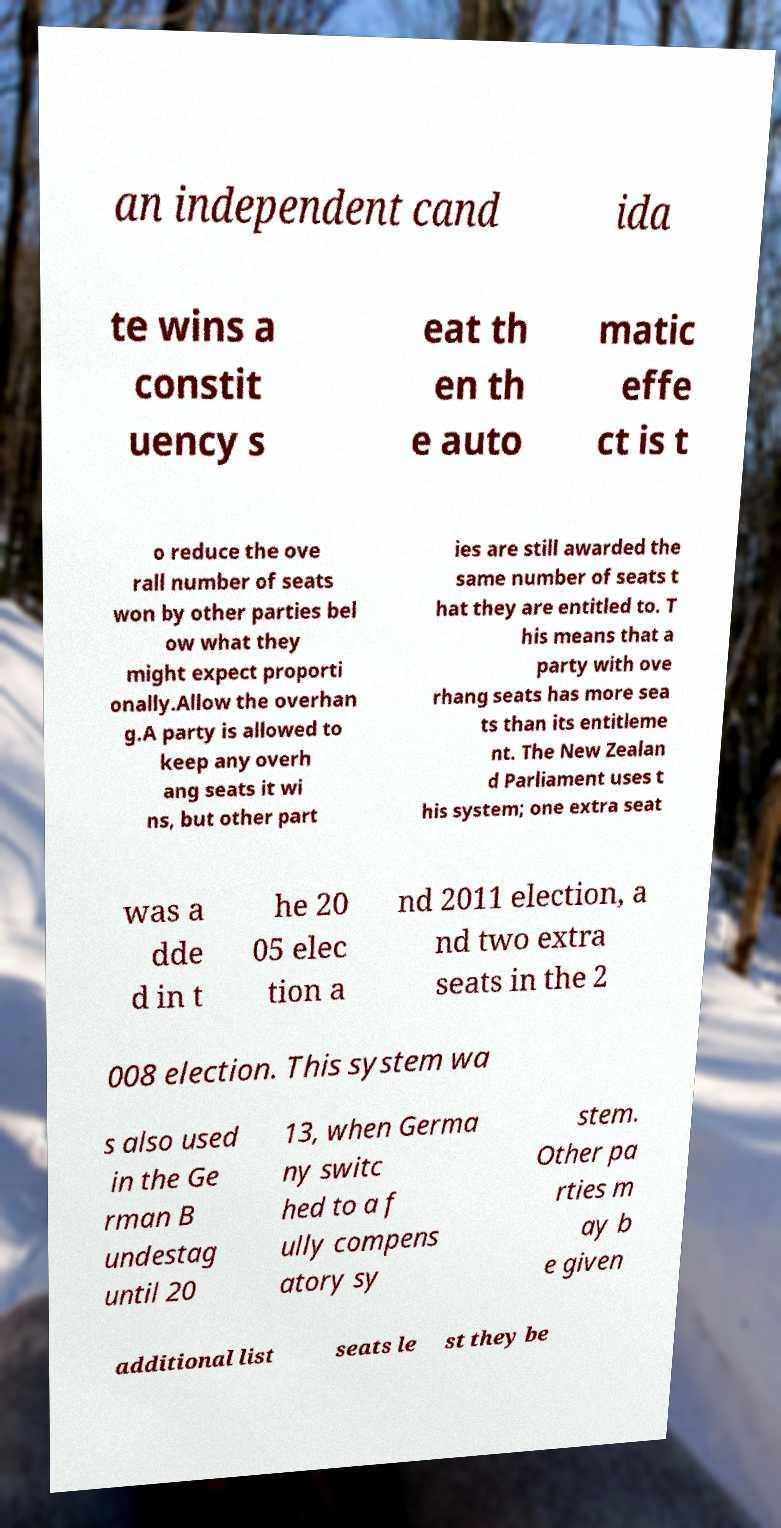Can you accurately transcribe the text from the provided image for me? an independent cand ida te wins a constit uency s eat th en th e auto matic effe ct is t o reduce the ove rall number of seats won by other parties bel ow what they might expect proporti onally.Allow the overhan g.A party is allowed to keep any overh ang seats it wi ns, but other part ies are still awarded the same number of seats t hat they are entitled to. T his means that a party with ove rhang seats has more sea ts than its entitleme nt. The New Zealan d Parliament uses t his system; one extra seat was a dde d in t he 20 05 elec tion a nd 2011 election, a nd two extra seats in the 2 008 election. This system wa s also used in the Ge rman B undestag until 20 13, when Germa ny switc hed to a f ully compens atory sy stem. Other pa rties m ay b e given additional list seats le st they be 